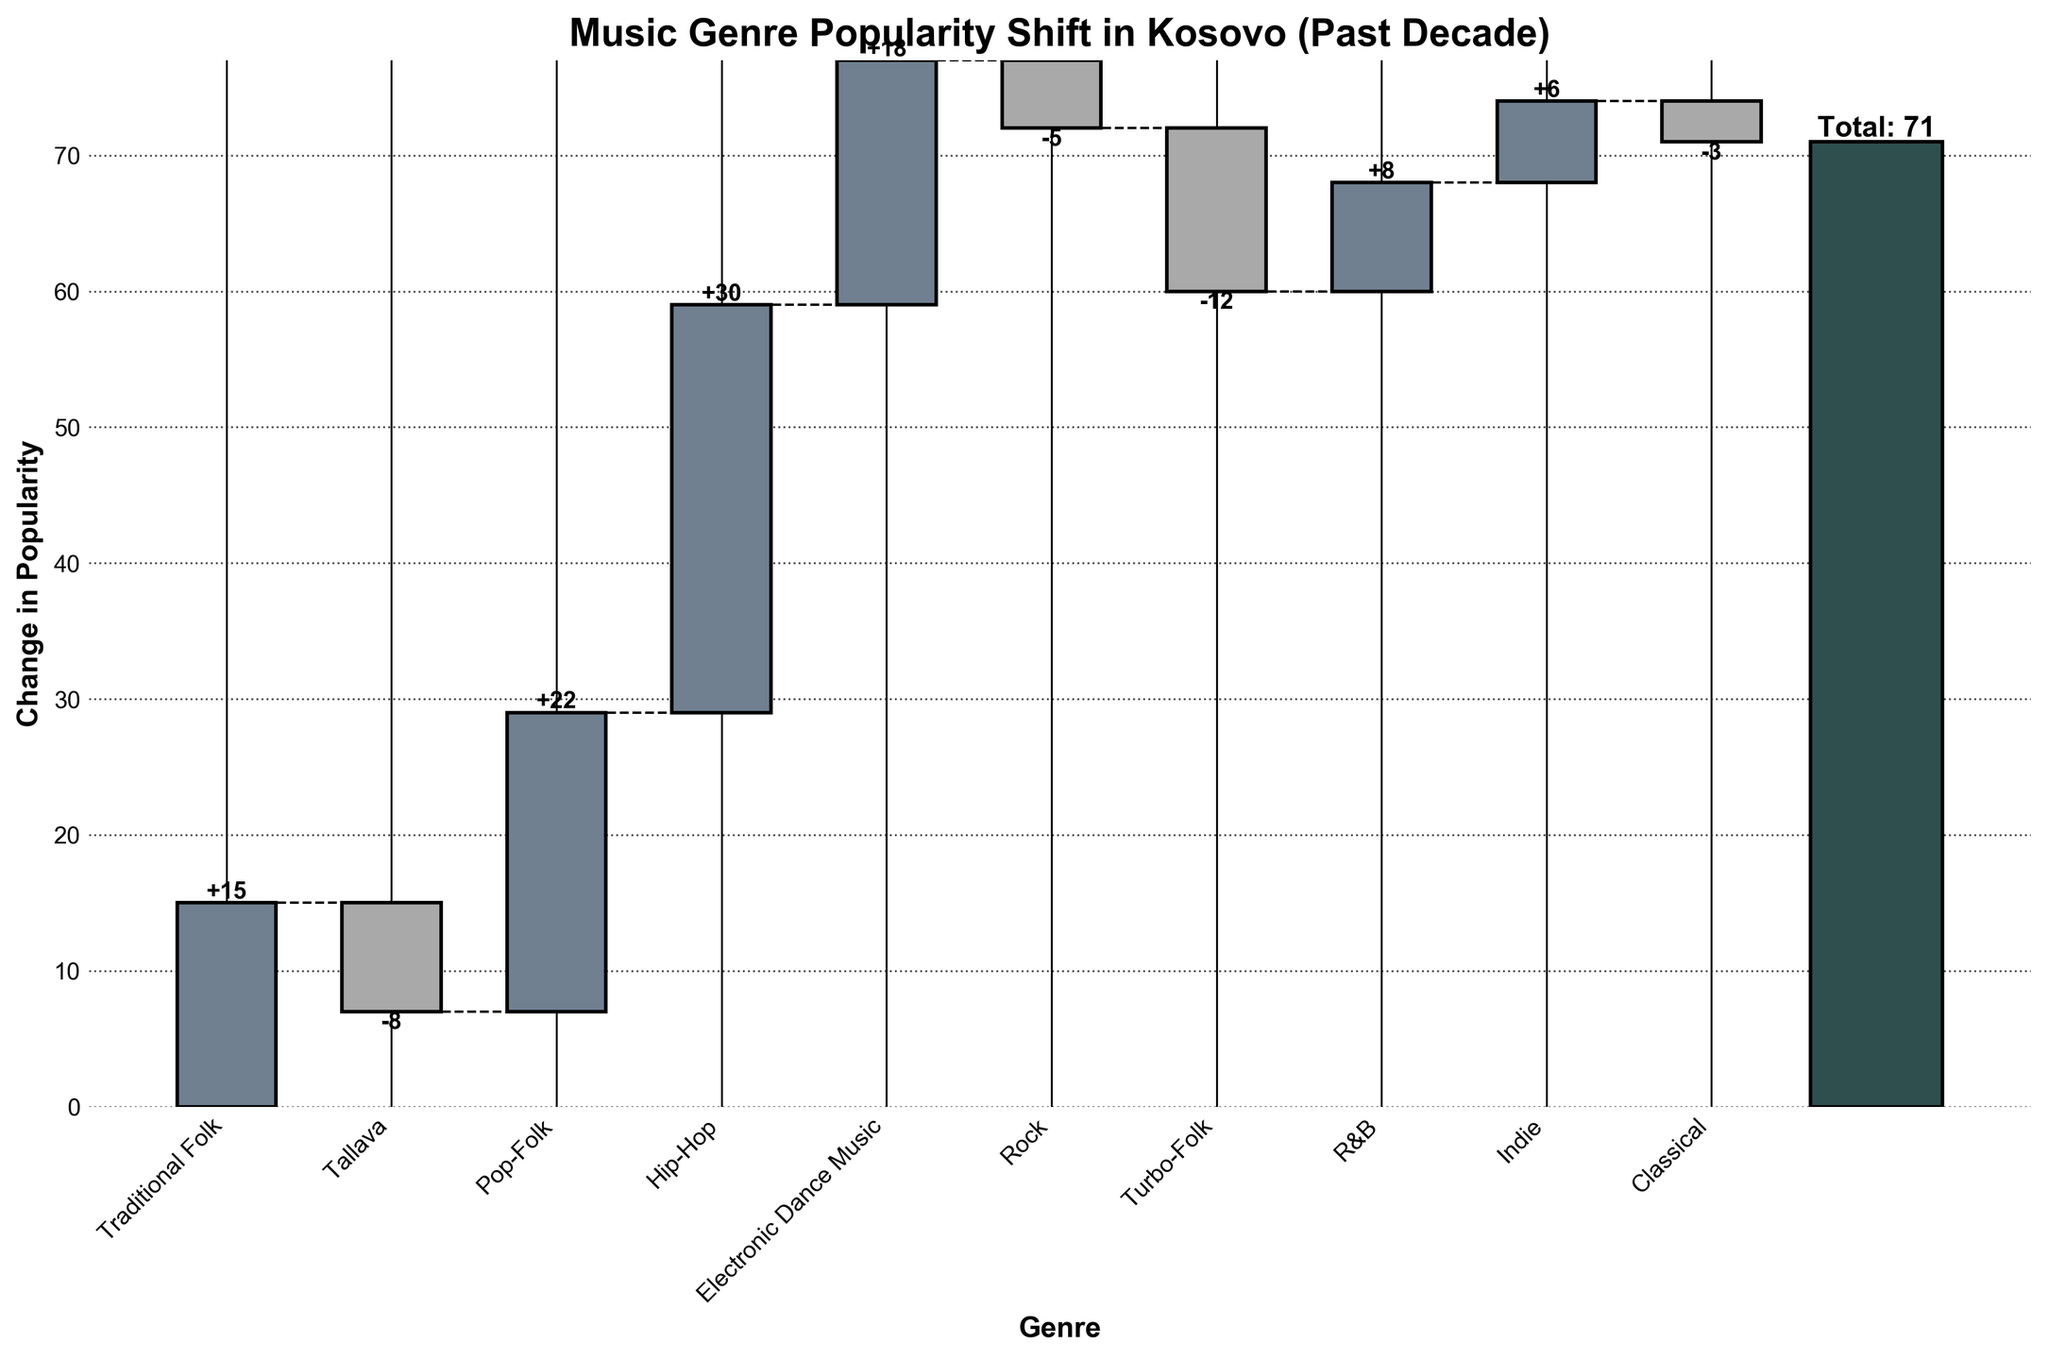What genre has experienced the most growth over the past decade? By looking at the height and positive direction of the bars in the chart, Hip-Hop shows the highest increase in popularity as its bar is the tallest among the increasing genres.
Answer: Hip-Hop Which traditional music-related genre showed a decline in popularity? In the chart, traditional genres like Tallava and Turbo-Folk have negative values. Hence, both of these traditional music-related genres have experienced a decline, but Turbo-Folk has a larger decline.
Answer: Turbo-Folk What is the total change in popularity of all music genres combined? By checking the final bar in the chart, which represents the total change in popularity for all genres combined, we can see it indicates a value of 71.
Answer: 71 How much did Pop-Folk increase in popularity? Referring to the height and positive value of the Pop-Folk bar, Pop-Folk increased by 22 units.
Answer: 22 Between Rock and Traditional Folk, which genre's popularity shifted more significantly, and in what direction? Rock has a decline of -5, while Traditional Folk increased by 15. Traditional Folk shifted more significantly with a positive change.
Answer: Traditional Folk, positive Which genre has the smallest change in popularity? Comparing the bar heights of all genres, Classical shows the smallest change in popularity with a -3 shift.
Answer: Classical How does the popularity shift in Electronic Dance Music compare to Hip-Hop? By comparing the bars for these two genres, Hip-Hop increased by 30, which is greater than Electronic Dance Music's increase of 18.
Answer: Hip-Hop has a higher increase Did Indie music popularity increase or decrease, and by how much? Observing the direction and value of the change in the Indie genre bar, Indie music increased by 6.
Answer: Increased by 6 What is the cumulative popularity change just before adding R&B? To calculate this, sum up the changes of all preceding genres: 15 (Traditional Folk) - 8 (Tallava) + 22 (Pop-Folk) + 30 (Hip-Hop) + 18 (Electronic Dance Music) - 5 (Rock) - 12 (Turbo-Folk) = 60
Answer: 60 What is the difference in the popularity change between the most and least changed genres? The largest increase is Hip-Hop at 30, and the largest decrease is Turbo-Folk at -12. The difference is calculated as 30 - (-12) = 42.
Answer: 42 